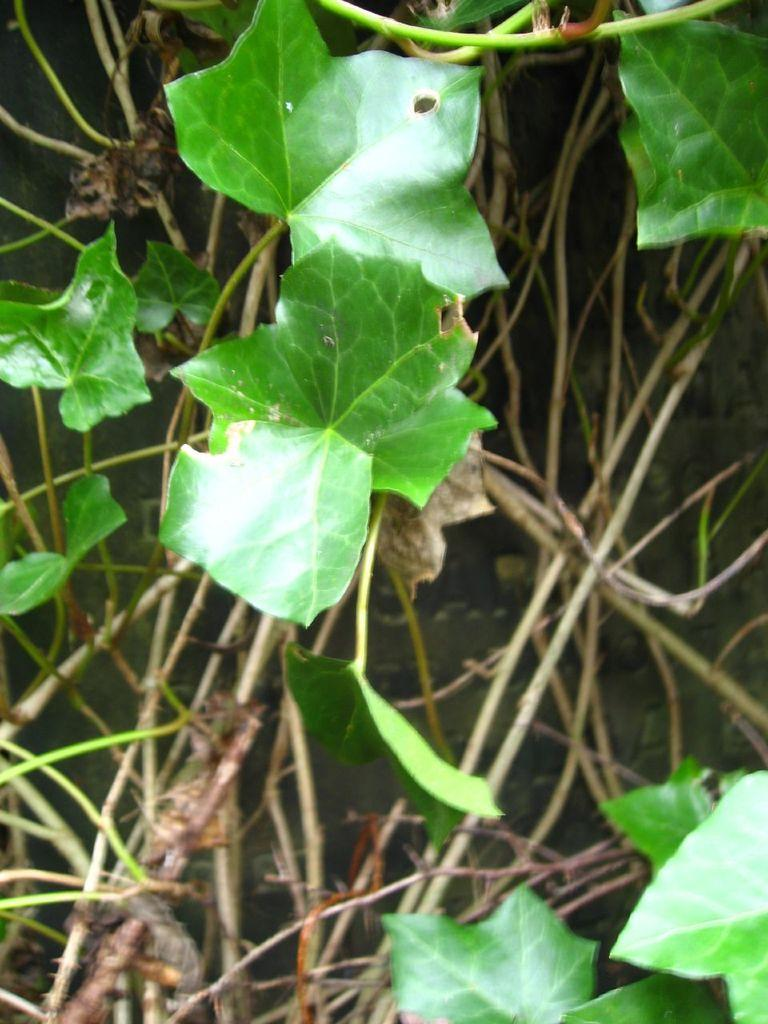What type of plant parts can be seen in the image? There are branches and leaves in the image. What do the branches and leaves belong to? The branches and leaves belong to a plant. How many eggs are visible on the branches in the image? There are no eggs present in the image; it only features branches and leaves. What type of arm is visible on the plant in the image? There is no arm present in the image; it only features branches and leaves. 